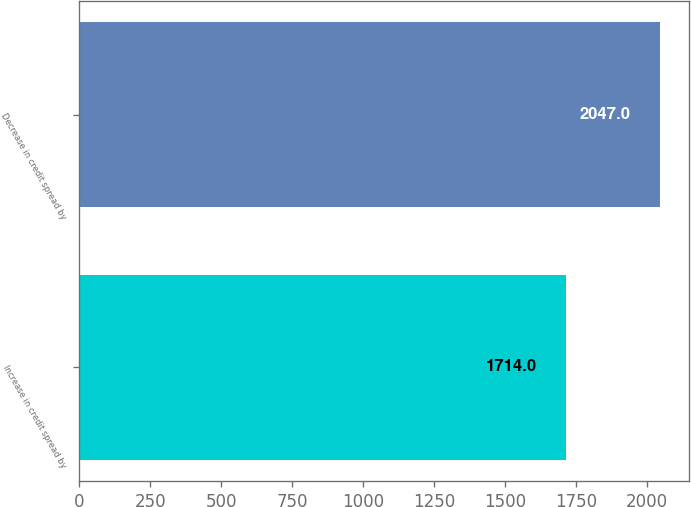<chart> <loc_0><loc_0><loc_500><loc_500><bar_chart><fcel>Increase in credit spread by<fcel>Decrease in credit spread by<nl><fcel>1714<fcel>2047<nl></chart> 